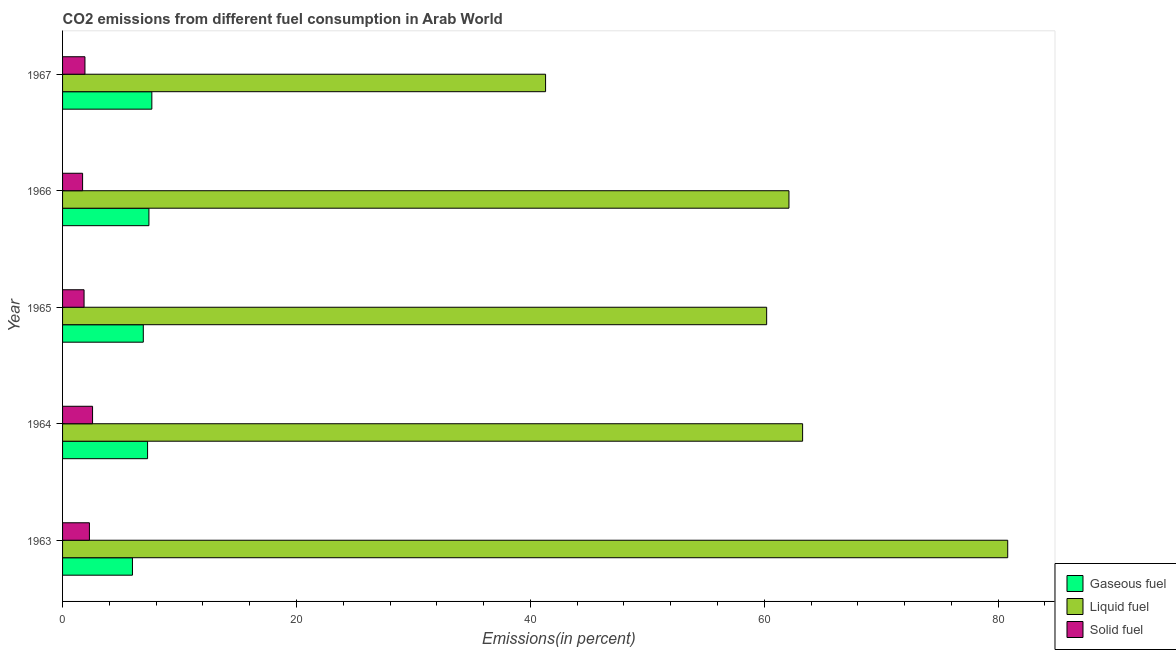How many different coloured bars are there?
Provide a short and direct response. 3. Are the number of bars on each tick of the Y-axis equal?
Your answer should be compact. Yes. How many bars are there on the 4th tick from the bottom?
Your response must be concise. 3. What is the label of the 4th group of bars from the top?
Provide a succinct answer. 1964. What is the percentage of gaseous fuel emission in 1967?
Your response must be concise. 7.63. Across all years, what is the maximum percentage of solid fuel emission?
Provide a succinct answer. 2.56. Across all years, what is the minimum percentage of liquid fuel emission?
Ensure brevity in your answer.  41.3. In which year was the percentage of gaseous fuel emission maximum?
Your answer should be very brief. 1967. In which year was the percentage of solid fuel emission minimum?
Make the answer very short. 1966. What is the total percentage of liquid fuel emission in the graph?
Offer a terse response. 307.73. What is the difference between the percentage of solid fuel emission in 1965 and that in 1967?
Give a very brief answer. -0.08. What is the difference between the percentage of solid fuel emission in 1964 and the percentage of gaseous fuel emission in 1966?
Make the answer very short. -4.82. What is the average percentage of gaseous fuel emission per year?
Give a very brief answer. 7.03. In the year 1963, what is the difference between the percentage of solid fuel emission and percentage of liquid fuel emission?
Your answer should be compact. -78.53. What is the ratio of the percentage of solid fuel emission in 1963 to that in 1966?
Give a very brief answer. 1.34. Is the percentage of liquid fuel emission in 1963 less than that in 1964?
Your response must be concise. No. Is the difference between the percentage of liquid fuel emission in 1963 and 1967 greater than the difference between the percentage of solid fuel emission in 1963 and 1967?
Provide a succinct answer. Yes. What is the difference between the highest and the second highest percentage of solid fuel emission?
Make the answer very short. 0.27. What is the difference between the highest and the lowest percentage of gaseous fuel emission?
Your answer should be compact. 1.66. Is the sum of the percentage of gaseous fuel emission in 1963 and 1967 greater than the maximum percentage of liquid fuel emission across all years?
Ensure brevity in your answer.  No. What does the 3rd bar from the top in 1963 represents?
Give a very brief answer. Gaseous fuel. What does the 1st bar from the bottom in 1965 represents?
Offer a terse response. Gaseous fuel. How many bars are there?
Make the answer very short. 15. Are all the bars in the graph horizontal?
Provide a short and direct response. Yes. How many years are there in the graph?
Make the answer very short. 5. What is the difference between two consecutive major ticks on the X-axis?
Your answer should be very brief. 20. Are the values on the major ticks of X-axis written in scientific E-notation?
Give a very brief answer. No. Does the graph contain grids?
Make the answer very short. No. Where does the legend appear in the graph?
Your response must be concise. Bottom right. How many legend labels are there?
Ensure brevity in your answer.  3. How are the legend labels stacked?
Your answer should be compact. Vertical. What is the title of the graph?
Make the answer very short. CO2 emissions from different fuel consumption in Arab World. What is the label or title of the X-axis?
Provide a short and direct response. Emissions(in percent). What is the label or title of the Y-axis?
Your response must be concise. Year. What is the Emissions(in percent) of Gaseous fuel in 1963?
Offer a terse response. 5.98. What is the Emissions(in percent) in Liquid fuel in 1963?
Your answer should be very brief. 80.82. What is the Emissions(in percent) in Solid fuel in 1963?
Offer a terse response. 2.3. What is the Emissions(in percent) in Gaseous fuel in 1964?
Give a very brief answer. 7.27. What is the Emissions(in percent) in Liquid fuel in 1964?
Offer a terse response. 63.28. What is the Emissions(in percent) in Solid fuel in 1964?
Your response must be concise. 2.56. What is the Emissions(in percent) of Gaseous fuel in 1965?
Provide a short and direct response. 6.9. What is the Emissions(in percent) of Liquid fuel in 1965?
Provide a succinct answer. 60.21. What is the Emissions(in percent) of Solid fuel in 1965?
Your answer should be very brief. 1.84. What is the Emissions(in percent) of Gaseous fuel in 1966?
Make the answer very short. 7.38. What is the Emissions(in percent) in Liquid fuel in 1966?
Give a very brief answer. 62.12. What is the Emissions(in percent) in Solid fuel in 1966?
Provide a succinct answer. 1.71. What is the Emissions(in percent) in Gaseous fuel in 1967?
Offer a terse response. 7.63. What is the Emissions(in percent) of Liquid fuel in 1967?
Your answer should be very brief. 41.3. What is the Emissions(in percent) of Solid fuel in 1967?
Give a very brief answer. 1.91. Across all years, what is the maximum Emissions(in percent) in Gaseous fuel?
Your answer should be compact. 7.63. Across all years, what is the maximum Emissions(in percent) of Liquid fuel?
Provide a succinct answer. 80.82. Across all years, what is the maximum Emissions(in percent) in Solid fuel?
Offer a terse response. 2.56. Across all years, what is the minimum Emissions(in percent) in Gaseous fuel?
Provide a short and direct response. 5.98. Across all years, what is the minimum Emissions(in percent) in Liquid fuel?
Your answer should be compact. 41.3. Across all years, what is the minimum Emissions(in percent) of Solid fuel?
Your response must be concise. 1.71. What is the total Emissions(in percent) of Gaseous fuel in the graph?
Keep it short and to the point. 35.17. What is the total Emissions(in percent) in Liquid fuel in the graph?
Your response must be concise. 307.73. What is the total Emissions(in percent) in Solid fuel in the graph?
Give a very brief answer. 10.33. What is the difference between the Emissions(in percent) of Gaseous fuel in 1963 and that in 1964?
Make the answer very short. -1.29. What is the difference between the Emissions(in percent) of Liquid fuel in 1963 and that in 1964?
Your response must be concise. 17.54. What is the difference between the Emissions(in percent) of Solid fuel in 1963 and that in 1964?
Provide a succinct answer. -0.27. What is the difference between the Emissions(in percent) of Gaseous fuel in 1963 and that in 1965?
Ensure brevity in your answer.  -0.93. What is the difference between the Emissions(in percent) of Liquid fuel in 1963 and that in 1965?
Provide a short and direct response. 20.61. What is the difference between the Emissions(in percent) in Solid fuel in 1963 and that in 1965?
Give a very brief answer. 0.46. What is the difference between the Emissions(in percent) in Gaseous fuel in 1963 and that in 1966?
Provide a succinct answer. -1.41. What is the difference between the Emissions(in percent) in Liquid fuel in 1963 and that in 1966?
Make the answer very short. 18.71. What is the difference between the Emissions(in percent) in Solid fuel in 1963 and that in 1966?
Offer a very short reply. 0.58. What is the difference between the Emissions(in percent) in Gaseous fuel in 1963 and that in 1967?
Provide a short and direct response. -1.66. What is the difference between the Emissions(in percent) in Liquid fuel in 1963 and that in 1967?
Provide a short and direct response. 39.52. What is the difference between the Emissions(in percent) of Solid fuel in 1963 and that in 1967?
Provide a short and direct response. 0.38. What is the difference between the Emissions(in percent) in Gaseous fuel in 1964 and that in 1965?
Make the answer very short. 0.37. What is the difference between the Emissions(in percent) of Liquid fuel in 1964 and that in 1965?
Your answer should be compact. 3.07. What is the difference between the Emissions(in percent) in Solid fuel in 1964 and that in 1965?
Your answer should be compact. 0.73. What is the difference between the Emissions(in percent) in Gaseous fuel in 1964 and that in 1966?
Offer a very short reply. -0.11. What is the difference between the Emissions(in percent) in Liquid fuel in 1964 and that in 1966?
Keep it short and to the point. 1.17. What is the difference between the Emissions(in percent) in Solid fuel in 1964 and that in 1966?
Your answer should be very brief. 0.85. What is the difference between the Emissions(in percent) in Gaseous fuel in 1964 and that in 1967?
Offer a terse response. -0.36. What is the difference between the Emissions(in percent) of Liquid fuel in 1964 and that in 1967?
Your answer should be compact. 21.98. What is the difference between the Emissions(in percent) in Solid fuel in 1964 and that in 1967?
Make the answer very short. 0.65. What is the difference between the Emissions(in percent) of Gaseous fuel in 1965 and that in 1966?
Offer a terse response. -0.48. What is the difference between the Emissions(in percent) in Liquid fuel in 1965 and that in 1966?
Your answer should be very brief. -1.91. What is the difference between the Emissions(in percent) in Solid fuel in 1965 and that in 1966?
Your response must be concise. 0.12. What is the difference between the Emissions(in percent) in Gaseous fuel in 1965 and that in 1967?
Your response must be concise. -0.73. What is the difference between the Emissions(in percent) of Liquid fuel in 1965 and that in 1967?
Your answer should be very brief. 18.91. What is the difference between the Emissions(in percent) of Solid fuel in 1965 and that in 1967?
Offer a very short reply. -0.08. What is the difference between the Emissions(in percent) of Gaseous fuel in 1966 and that in 1967?
Your answer should be very brief. -0.25. What is the difference between the Emissions(in percent) in Liquid fuel in 1966 and that in 1967?
Your answer should be very brief. 20.81. What is the difference between the Emissions(in percent) in Solid fuel in 1966 and that in 1967?
Ensure brevity in your answer.  -0.2. What is the difference between the Emissions(in percent) of Gaseous fuel in 1963 and the Emissions(in percent) of Liquid fuel in 1964?
Your answer should be compact. -57.31. What is the difference between the Emissions(in percent) of Gaseous fuel in 1963 and the Emissions(in percent) of Solid fuel in 1964?
Offer a very short reply. 3.41. What is the difference between the Emissions(in percent) of Liquid fuel in 1963 and the Emissions(in percent) of Solid fuel in 1964?
Provide a short and direct response. 78.26. What is the difference between the Emissions(in percent) of Gaseous fuel in 1963 and the Emissions(in percent) of Liquid fuel in 1965?
Keep it short and to the point. -54.23. What is the difference between the Emissions(in percent) of Gaseous fuel in 1963 and the Emissions(in percent) of Solid fuel in 1965?
Your response must be concise. 4.14. What is the difference between the Emissions(in percent) in Liquid fuel in 1963 and the Emissions(in percent) in Solid fuel in 1965?
Your answer should be very brief. 78.98. What is the difference between the Emissions(in percent) of Gaseous fuel in 1963 and the Emissions(in percent) of Liquid fuel in 1966?
Provide a succinct answer. -56.14. What is the difference between the Emissions(in percent) of Gaseous fuel in 1963 and the Emissions(in percent) of Solid fuel in 1966?
Give a very brief answer. 4.26. What is the difference between the Emissions(in percent) in Liquid fuel in 1963 and the Emissions(in percent) in Solid fuel in 1966?
Give a very brief answer. 79.11. What is the difference between the Emissions(in percent) in Gaseous fuel in 1963 and the Emissions(in percent) in Liquid fuel in 1967?
Give a very brief answer. -35.33. What is the difference between the Emissions(in percent) of Gaseous fuel in 1963 and the Emissions(in percent) of Solid fuel in 1967?
Offer a very short reply. 4.06. What is the difference between the Emissions(in percent) of Liquid fuel in 1963 and the Emissions(in percent) of Solid fuel in 1967?
Your response must be concise. 78.91. What is the difference between the Emissions(in percent) of Gaseous fuel in 1964 and the Emissions(in percent) of Liquid fuel in 1965?
Offer a terse response. -52.94. What is the difference between the Emissions(in percent) of Gaseous fuel in 1964 and the Emissions(in percent) of Solid fuel in 1965?
Keep it short and to the point. 5.43. What is the difference between the Emissions(in percent) of Liquid fuel in 1964 and the Emissions(in percent) of Solid fuel in 1965?
Your answer should be compact. 61.45. What is the difference between the Emissions(in percent) in Gaseous fuel in 1964 and the Emissions(in percent) in Liquid fuel in 1966?
Keep it short and to the point. -54.84. What is the difference between the Emissions(in percent) in Gaseous fuel in 1964 and the Emissions(in percent) in Solid fuel in 1966?
Provide a short and direct response. 5.56. What is the difference between the Emissions(in percent) in Liquid fuel in 1964 and the Emissions(in percent) in Solid fuel in 1966?
Your answer should be compact. 61.57. What is the difference between the Emissions(in percent) in Gaseous fuel in 1964 and the Emissions(in percent) in Liquid fuel in 1967?
Keep it short and to the point. -34.03. What is the difference between the Emissions(in percent) in Gaseous fuel in 1964 and the Emissions(in percent) in Solid fuel in 1967?
Ensure brevity in your answer.  5.36. What is the difference between the Emissions(in percent) in Liquid fuel in 1964 and the Emissions(in percent) in Solid fuel in 1967?
Keep it short and to the point. 61.37. What is the difference between the Emissions(in percent) of Gaseous fuel in 1965 and the Emissions(in percent) of Liquid fuel in 1966?
Make the answer very short. -55.21. What is the difference between the Emissions(in percent) in Gaseous fuel in 1965 and the Emissions(in percent) in Solid fuel in 1966?
Your response must be concise. 5.19. What is the difference between the Emissions(in percent) of Liquid fuel in 1965 and the Emissions(in percent) of Solid fuel in 1966?
Provide a short and direct response. 58.5. What is the difference between the Emissions(in percent) of Gaseous fuel in 1965 and the Emissions(in percent) of Liquid fuel in 1967?
Give a very brief answer. -34.4. What is the difference between the Emissions(in percent) in Gaseous fuel in 1965 and the Emissions(in percent) in Solid fuel in 1967?
Make the answer very short. 4.99. What is the difference between the Emissions(in percent) in Liquid fuel in 1965 and the Emissions(in percent) in Solid fuel in 1967?
Keep it short and to the point. 58.29. What is the difference between the Emissions(in percent) in Gaseous fuel in 1966 and the Emissions(in percent) in Liquid fuel in 1967?
Offer a terse response. -33.92. What is the difference between the Emissions(in percent) in Gaseous fuel in 1966 and the Emissions(in percent) in Solid fuel in 1967?
Offer a very short reply. 5.47. What is the difference between the Emissions(in percent) in Liquid fuel in 1966 and the Emissions(in percent) in Solid fuel in 1967?
Keep it short and to the point. 60.2. What is the average Emissions(in percent) of Gaseous fuel per year?
Provide a succinct answer. 7.03. What is the average Emissions(in percent) of Liquid fuel per year?
Your answer should be very brief. 61.55. What is the average Emissions(in percent) of Solid fuel per year?
Your answer should be very brief. 2.07. In the year 1963, what is the difference between the Emissions(in percent) in Gaseous fuel and Emissions(in percent) in Liquid fuel?
Provide a short and direct response. -74.85. In the year 1963, what is the difference between the Emissions(in percent) in Gaseous fuel and Emissions(in percent) in Solid fuel?
Give a very brief answer. 3.68. In the year 1963, what is the difference between the Emissions(in percent) in Liquid fuel and Emissions(in percent) in Solid fuel?
Provide a succinct answer. 78.52. In the year 1964, what is the difference between the Emissions(in percent) of Gaseous fuel and Emissions(in percent) of Liquid fuel?
Make the answer very short. -56.01. In the year 1964, what is the difference between the Emissions(in percent) in Gaseous fuel and Emissions(in percent) in Solid fuel?
Keep it short and to the point. 4.71. In the year 1964, what is the difference between the Emissions(in percent) of Liquid fuel and Emissions(in percent) of Solid fuel?
Your answer should be compact. 60.72. In the year 1965, what is the difference between the Emissions(in percent) in Gaseous fuel and Emissions(in percent) in Liquid fuel?
Make the answer very short. -53.31. In the year 1965, what is the difference between the Emissions(in percent) in Gaseous fuel and Emissions(in percent) in Solid fuel?
Offer a terse response. 5.07. In the year 1965, what is the difference between the Emissions(in percent) in Liquid fuel and Emissions(in percent) in Solid fuel?
Your response must be concise. 58.37. In the year 1966, what is the difference between the Emissions(in percent) of Gaseous fuel and Emissions(in percent) of Liquid fuel?
Your answer should be compact. -54.73. In the year 1966, what is the difference between the Emissions(in percent) in Gaseous fuel and Emissions(in percent) in Solid fuel?
Your answer should be very brief. 5.67. In the year 1966, what is the difference between the Emissions(in percent) in Liquid fuel and Emissions(in percent) in Solid fuel?
Your answer should be compact. 60.4. In the year 1967, what is the difference between the Emissions(in percent) of Gaseous fuel and Emissions(in percent) of Liquid fuel?
Your answer should be very brief. -33.67. In the year 1967, what is the difference between the Emissions(in percent) of Gaseous fuel and Emissions(in percent) of Solid fuel?
Provide a short and direct response. 5.72. In the year 1967, what is the difference between the Emissions(in percent) in Liquid fuel and Emissions(in percent) in Solid fuel?
Keep it short and to the point. 39.39. What is the ratio of the Emissions(in percent) in Gaseous fuel in 1963 to that in 1964?
Give a very brief answer. 0.82. What is the ratio of the Emissions(in percent) in Liquid fuel in 1963 to that in 1964?
Offer a terse response. 1.28. What is the ratio of the Emissions(in percent) of Solid fuel in 1963 to that in 1964?
Provide a short and direct response. 0.9. What is the ratio of the Emissions(in percent) in Gaseous fuel in 1963 to that in 1965?
Give a very brief answer. 0.87. What is the ratio of the Emissions(in percent) of Liquid fuel in 1963 to that in 1965?
Ensure brevity in your answer.  1.34. What is the ratio of the Emissions(in percent) in Solid fuel in 1963 to that in 1965?
Ensure brevity in your answer.  1.25. What is the ratio of the Emissions(in percent) of Gaseous fuel in 1963 to that in 1966?
Make the answer very short. 0.81. What is the ratio of the Emissions(in percent) of Liquid fuel in 1963 to that in 1966?
Provide a succinct answer. 1.3. What is the ratio of the Emissions(in percent) of Solid fuel in 1963 to that in 1966?
Make the answer very short. 1.34. What is the ratio of the Emissions(in percent) of Gaseous fuel in 1963 to that in 1967?
Provide a succinct answer. 0.78. What is the ratio of the Emissions(in percent) of Liquid fuel in 1963 to that in 1967?
Your answer should be compact. 1.96. What is the ratio of the Emissions(in percent) in Solid fuel in 1963 to that in 1967?
Provide a succinct answer. 1.2. What is the ratio of the Emissions(in percent) in Gaseous fuel in 1964 to that in 1965?
Provide a short and direct response. 1.05. What is the ratio of the Emissions(in percent) in Liquid fuel in 1964 to that in 1965?
Provide a succinct answer. 1.05. What is the ratio of the Emissions(in percent) in Solid fuel in 1964 to that in 1965?
Make the answer very short. 1.4. What is the ratio of the Emissions(in percent) in Gaseous fuel in 1964 to that in 1966?
Your response must be concise. 0.98. What is the ratio of the Emissions(in percent) of Liquid fuel in 1964 to that in 1966?
Provide a short and direct response. 1.02. What is the ratio of the Emissions(in percent) in Solid fuel in 1964 to that in 1966?
Provide a short and direct response. 1.5. What is the ratio of the Emissions(in percent) in Liquid fuel in 1964 to that in 1967?
Give a very brief answer. 1.53. What is the ratio of the Emissions(in percent) of Solid fuel in 1964 to that in 1967?
Offer a very short reply. 1.34. What is the ratio of the Emissions(in percent) in Gaseous fuel in 1965 to that in 1966?
Offer a terse response. 0.93. What is the ratio of the Emissions(in percent) in Liquid fuel in 1965 to that in 1966?
Your answer should be compact. 0.97. What is the ratio of the Emissions(in percent) in Solid fuel in 1965 to that in 1966?
Provide a succinct answer. 1.07. What is the ratio of the Emissions(in percent) in Gaseous fuel in 1965 to that in 1967?
Make the answer very short. 0.9. What is the ratio of the Emissions(in percent) of Liquid fuel in 1965 to that in 1967?
Keep it short and to the point. 1.46. What is the ratio of the Emissions(in percent) of Solid fuel in 1965 to that in 1967?
Ensure brevity in your answer.  0.96. What is the ratio of the Emissions(in percent) of Gaseous fuel in 1966 to that in 1967?
Your response must be concise. 0.97. What is the ratio of the Emissions(in percent) of Liquid fuel in 1966 to that in 1967?
Offer a terse response. 1.5. What is the ratio of the Emissions(in percent) in Solid fuel in 1966 to that in 1967?
Give a very brief answer. 0.89. What is the difference between the highest and the second highest Emissions(in percent) of Gaseous fuel?
Provide a succinct answer. 0.25. What is the difference between the highest and the second highest Emissions(in percent) of Liquid fuel?
Your response must be concise. 17.54. What is the difference between the highest and the second highest Emissions(in percent) in Solid fuel?
Provide a succinct answer. 0.27. What is the difference between the highest and the lowest Emissions(in percent) of Gaseous fuel?
Ensure brevity in your answer.  1.66. What is the difference between the highest and the lowest Emissions(in percent) of Liquid fuel?
Provide a short and direct response. 39.52. What is the difference between the highest and the lowest Emissions(in percent) in Solid fuel?
Your response must be concise. 0.85. 